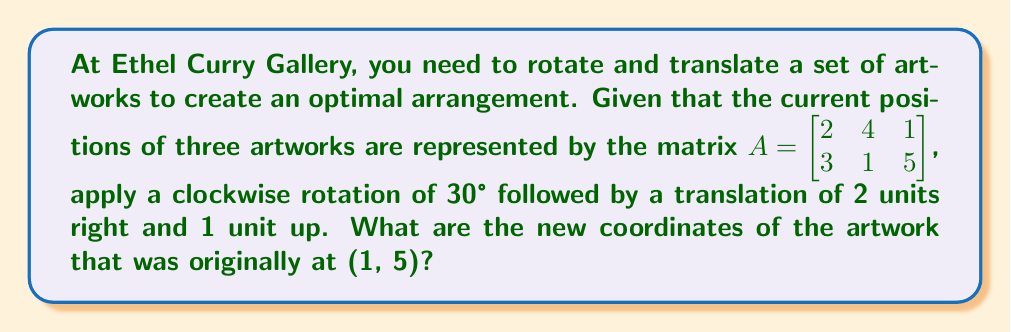Give your solution to this math problem. Let's approach this step-by-step:

1) First, we need to create the rotation matrix for a 30° clockwise rotation:
   $R = \begin{bmatrix} \cos 30° & \sin 30° \\ -\sin 30° & \cos 30° \end{bmatrix} = \begin{bmatrix} \frac{\sqrt{3}}{2} & \frac{1}{2} \\ -\frac{1}{2} & \frac{\sqrt{3}}{2} \end{bmatrix}$

2) Next, we apply this rotation to our original matrix A:
   $RA = \begin{bmatrix} \frac{\sqrt{3}}{2} & \frac{1}{2} \\ -\frac{1}{2} & \frac{\sqrt{3}}{2} \end{bmatrix} \begin{bmatrix} 2 & 4 & 1 \\ 3 & 1 & 5 \end{bmatrix}$

3) Let's focus on the third column, which represents the artwork at (1, 5):
   $\begin{bmatrix} \frac{\sqrt{3}}{2} & \frac{1}{2} \\ -\frac{1}{2} & \frac{\sqrt{3}}{2} \end{bmatrix} \begin{bmatrix} 1 \\ 5 \end{bmatrix} = \begin{bmatrix} \frac{\sqrt{3}}{2} + \frac{5}{2} \\ -\frac{1}{2} + \frac{5\sqrt{3}}{2} \end{bmatrix}$

4) Simplify:
   $\begin{bmatrix} \frac{\sqrt{3} + 5}{2} \\ \frac{-1 + 5\sqrt{3}}{2} \end{bmatrix}$

5) Now we need to apply the translation. We add 2 to the x-coordinate and 1 to the y-coordinate:
   $\begin{bmatrix} \frac{\sqrt{3} + 5}{2} + 2 \\ \frac{-1 + 5\sqrt{3}}{2} + 1 \end{bmatrix} = \begin{bmatrix} \frac{\sqrt{3} + 9}{2} \\ \frac{1 + 5\sqrt{3}}{2} \end{bmatrix}$

6) This is our final result. We can leave it in this form or approximate the decimal values if needed.
Answer: $\left(\frac{\sqrt{3} + 9}{2}, \frac{1 + 5\sqrt{3}}{2}\right)$ 